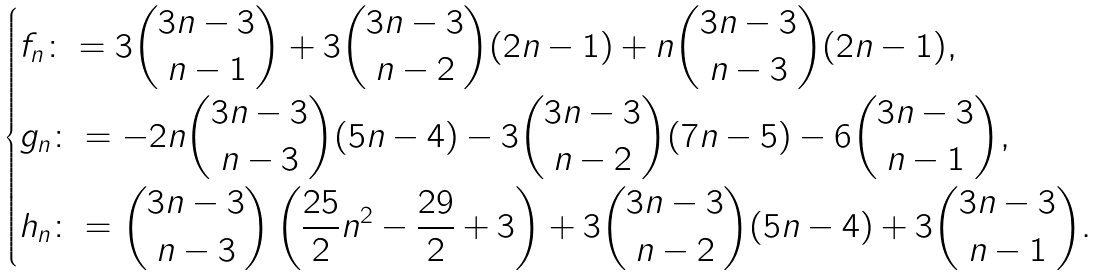<formula> <loc_0><loc_0><loc_500><loc_500>\begin{dcases} f _ { n } \colon = 3 { 3 n - 3 \choose n - 1 } + 3 { 3 n - 3 \choose n - 2 } ( 2 n - 1 ) + n { 3 n - 3 \choose n - 3 } ( 2 n - 1 ) , \\ g _ { n } \colon = - 2 n { 3 n - 3 \choose n - 3 } ( 5 n - 4 ) - 3 { 3 n - 3 \choose n - 2 } ( 7 n - 5 ) - 6 { 3 n - 3 \choose n - 1 } , \\ h _ { n } \colon = { 3 n - 3 \choose n - 3 } \left ( \frac { 2 5 } { 2 } n ^ { 2 } - \frac { 2 9 } { 2 } + 3 \right ) + 3 { 3 n - 3 \choose n - 2 } ( 5 n - 4 ) + 3 { 3 n - 3 \choose n - 1 } . \end{dcases}</formula> 